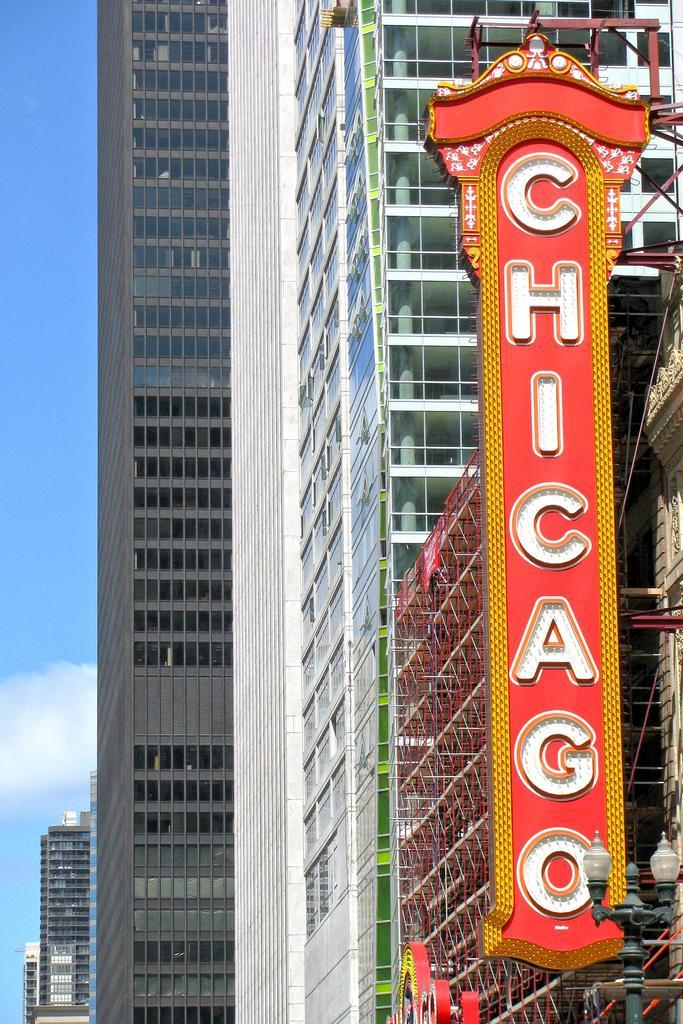What structure can be seen in the image? There is a light pole in the image. What else is visible in the image besides the light pole? There are boards to a building in the image. What can be seen in the background of the image? There are more buildings visible in the background of the image. What is the condition of the sky in the image? The sky is blue, and there are clouds visible. What type of market can be seen in the image? There is no market present in the image. What effect does the play have on the buildings in the image? There is no play or any indication of an effect on the buildings in the image. 